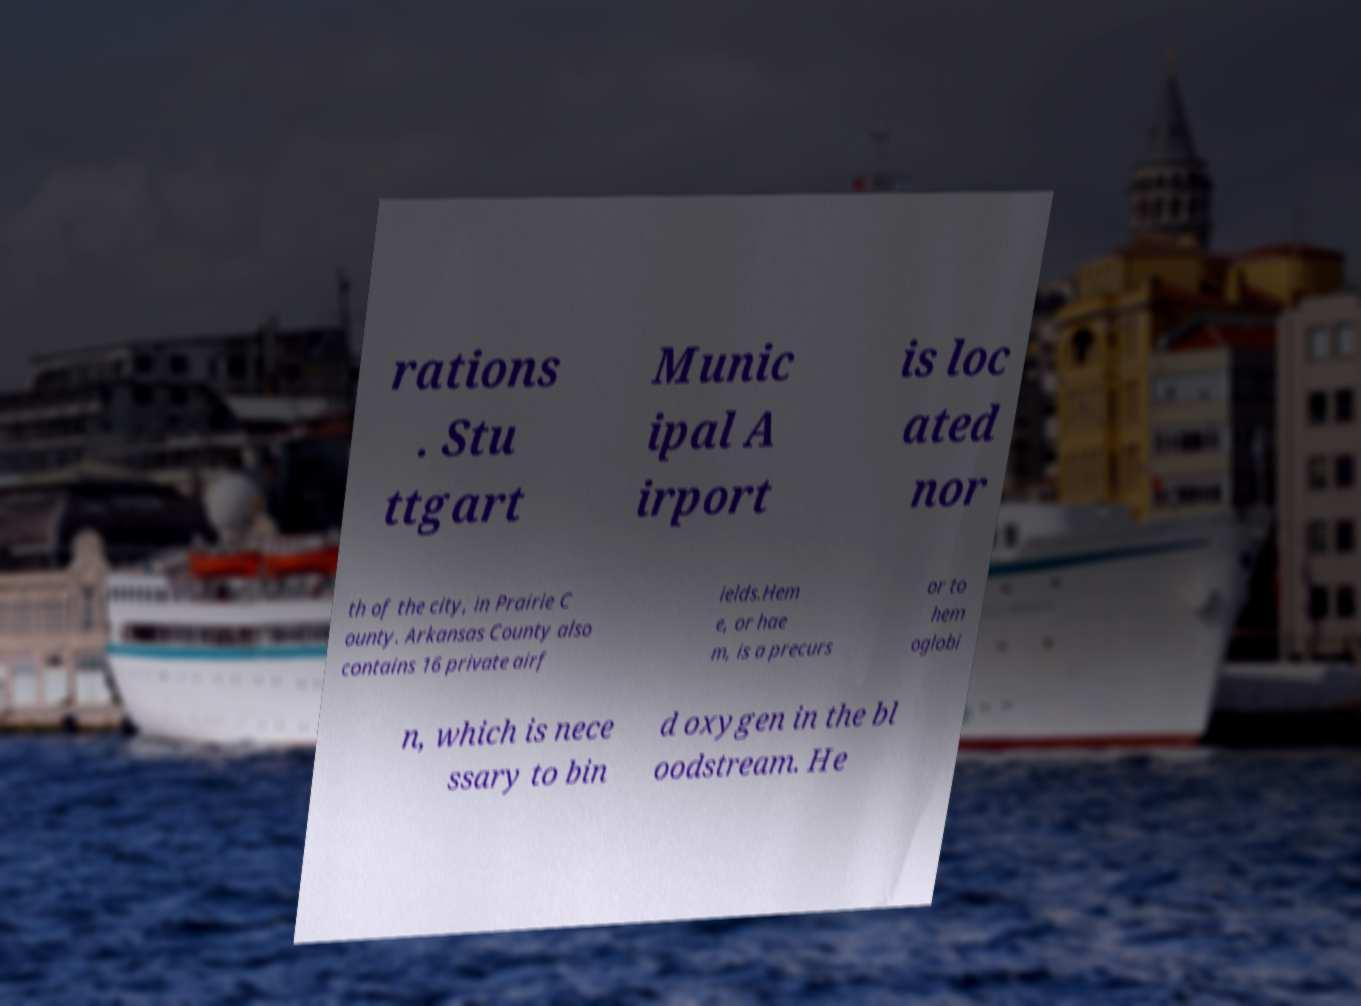There's text embedded in this image that I need extracted. Can you transcribe it verbatim? rations . Stu ttgart Munic ipal A irport is loc ated nor th of the city, in Prairie C ounty. Arkansas County also contains 16 private airf ields.Hem e, or hae m, is a precurs or to hem oglobi n, which is nece ssary to bin d oxygen in the bl oodstream. He 